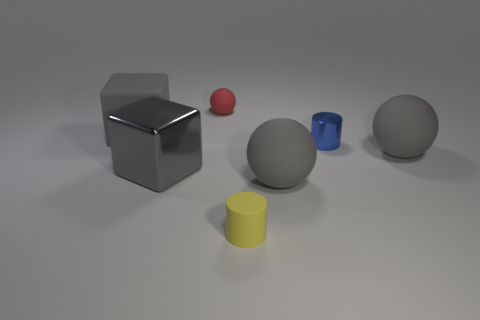Is there a cube?
Provide a succinct answer. Yes. Are there the same number of shiny cylinders that are in front of the blue metal thing and tiny things?
Keep it short and to the point. No. What number of other things are the same shape as the small yellow rubber object?
Provide a succinct answer. 1. What is the shape of the small blue shiny object?
Provide a succinct answer. Cylinder. Do the tiny red sphere and the small yellow cylinder have the same material?
Your answer should be very brief. Yes. Are there the same number of gray rubber spheres on the left side of the small metal object and yellow matte cylinders that are behind the matte cylinder?
Provide a short and direct response. No. There is a big ball in front of the gray sphere behind the big metal block; are there any tiny blue metallic cylinders to the left of it?
Offer a very short reply. No. Is the size of the matte cylinder the same as the blue shiny cylinder?
Your answer should be compact. Yes. There is a big shiny cube in front of the object behind the gray block behind the blue shiny cylinder; what is its color?
Your response must be concise. Gray. What number of spheres have the same color as the big rubber block?
Offer a terse response. 2. 